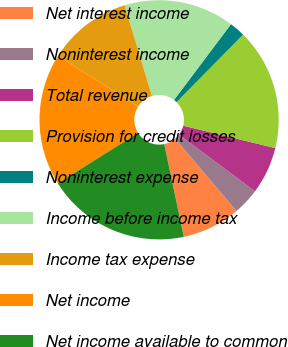<chart> <loc_0><loc_0><loc_500><loc_500><pie_chart><fcel>Net interest income<fcel>Noninterest income<fcel>Total revenue<fcel>Provision for credit losses<fcel>Noninterest expense<fcel>Income before income tax<fcel>Income tax expense<fcel>Net income<fcel>Net income available to common<nl><fcel>7.88%<fcel>3.62%<fcel>6.39%<fcel>16.41%<fcel>2.13%<fcel>14.91%<fcel>11.36%<fcel>17.9%<fcel>19.39%<nl></chart> 